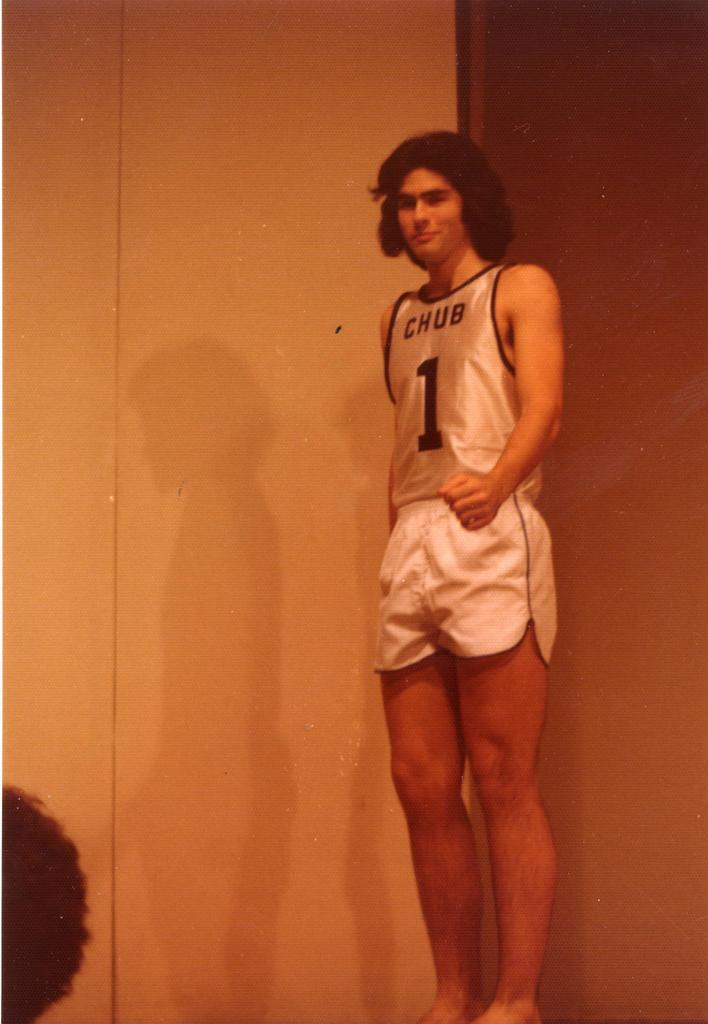<image>
Share a concise interpretation of the image provided. A young man in shorts and a sleeveless shirt has the number 1 on his shirt under the word CHUB. 